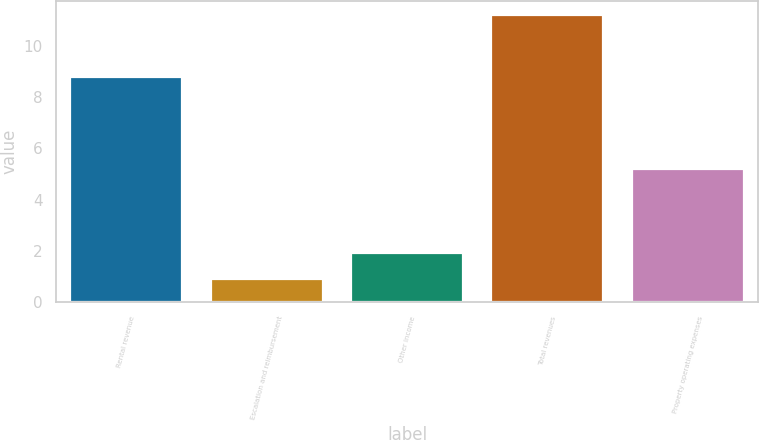Convert chart. <chart><loc_0><loc_0><loc_500><loc_500><bar_chart><fcel>Rental revenue<fcel>Escalation and reimbursement<fcel>Other income<fcel>Total revenues<fcel>Property operating expenses<nl><fcel>8.8<fcel>0.9<fcel>1.93<fcel>11.2<fcel>5.2<nl></chart> 